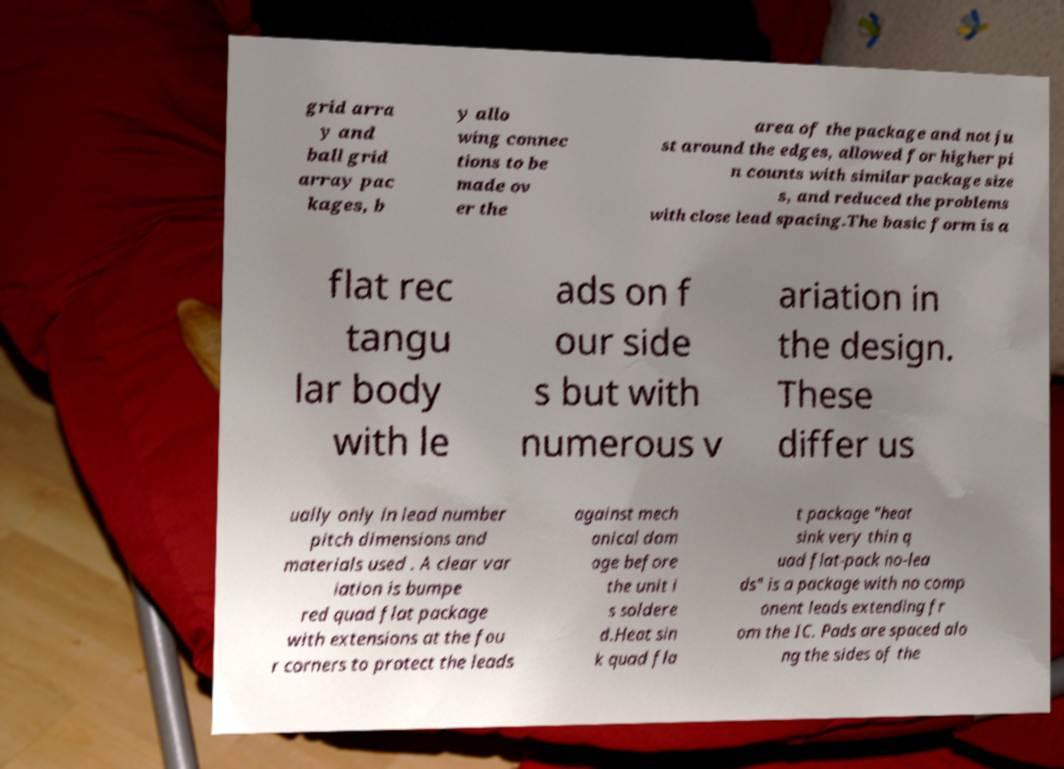Can you read and provide the text displayed in the image?This photo seems to have some interesting text. Can you extract and type it out for me? grid arra y and ball grid array pac kages, b y allo wing connec tions to be made ov er the area of the package and not ju st around the edges, allowed for higher pi n counts with similar package size s, and reduced the problems with close lead spacing.The basic form is a flat rec tangu lar body with le ads on f our side s but with numerous v ariation in the design. These differ us ually only in lead number pitch dimensions and materials used . A clear var iation is bumpe red quad flat package with extensions at the fou r corners to protect the leads against mech anical dam age before the unit i s soldere d.Heat sin k quad fla t package "heat sink very thin q uad flat-pack no-lea ds" is a package with no comp onent leads extending fr om the IC. Pads are spaced alo ng the sides of the 